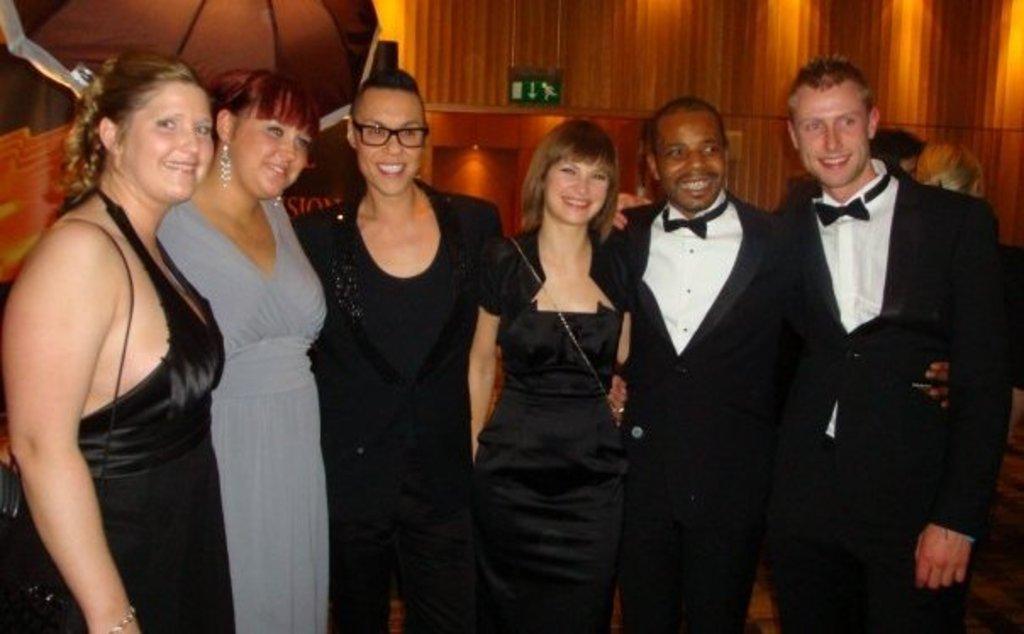How would you summarize this image in a sentence or two? In this image in the front there are group of persons standing and smiling. In the background there is a board which is green in colour showing some signs and on the right side there are persons and on the left side there is an object which is black in colour. 